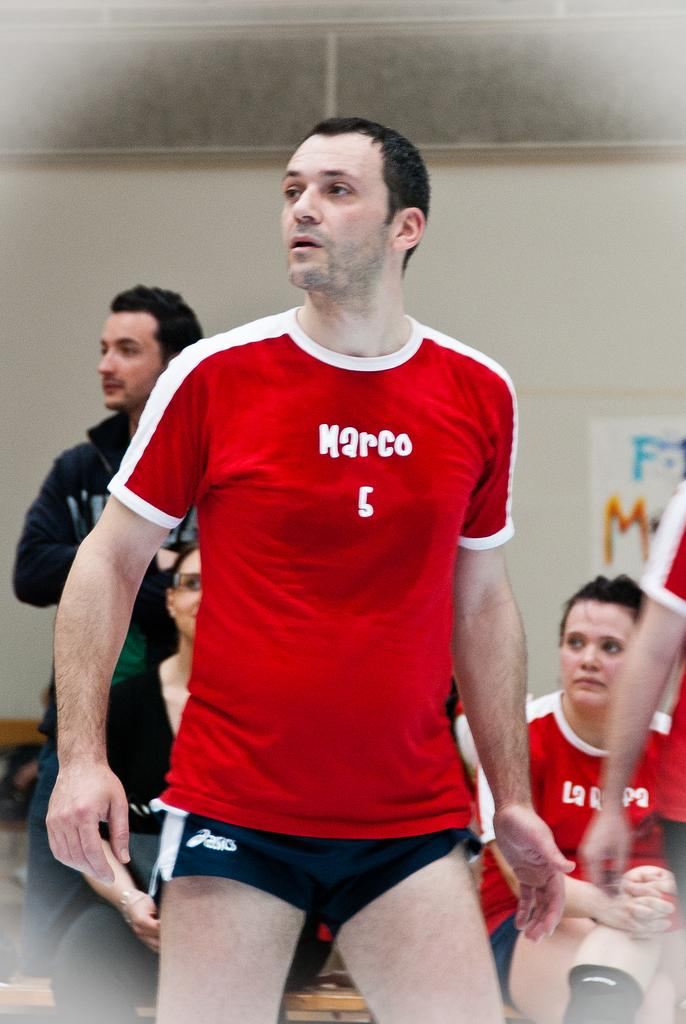<image>
Relay a brief, clear account of the picture shown. A man wearing a red athletic shirt that reads "Marco" looks on to his right. 